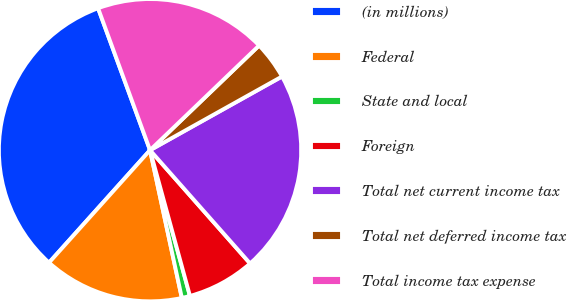Convert chart to OTSL. <chart><loc_0><loc_0><loc_500><loc_500><pie_chart><fcel>(in millions)<fcel>Federal<fcel>State and local<fcel>Foreign<fcel>Total net current income tax<fcel>Total net deferred income tax<fcel>Total income tax expense<nl><fcel>32.77%<fcel>15.02%<fcel>0.88%<fcel>7.26%<fcel>21.59%<fcel>4.07%<fcel>18.41%<nl></chart> 